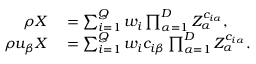<formula> <loc_0><loc_0><loc_500><loc_500>\begin{array} { r l } { \rho X } & = \sum _ { i = 1 } ^ { Q } w _ { i } \prod _ { \alpha = 1 } ^ { D } Z _ { \alpha } ^ { c _ { i \alpha } } , } \\ { \rho u _ { \beta } X } & = \sum _ { i = 1 } ^ { Q } w _ { i } c _ { i \beta } \prod _ { \alpha = 1 } ^ { D } Z _ { \alpha } ^ { c _ { i \alpha } } . } \end{array}</formula> 